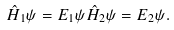<formula> <loc_0><loc_0><loc_500><loc_500>\hat { H } _ { 1 } \psi = E _ { 1 } \psi \hat { H } _ { 2 } \psi = E _ { 2 } \psi .</formula> 